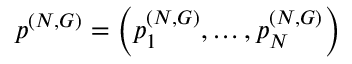Convert formula to latex. <formula><loc_0><loc_0><loc_500><loc_500>p ^ { ( N , G ) } = \left ( p _ { 1 } ^ { ( N , G ) } , \dots , p _ { N } ^ { ( N , G ) } \right )</formula> 